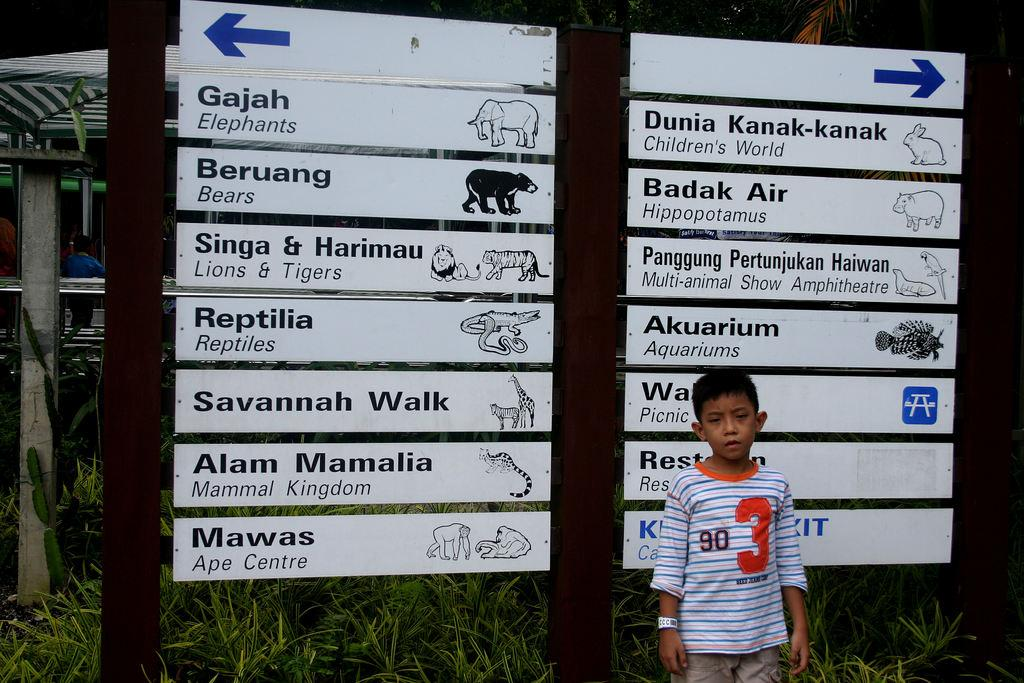Who is present in the image? There is a boy in the image. What is the boy standing near? The boy is standing near a board. What can be found on the board? The board contains text and animal figures. What is visible in the foreground of the image? There is grass visible in the foreground of the image. What type of bedroom furniture can be seen in the image? There is no bedroom furniture present in the image; it features a boy standing near a board with text and animal figures. What kind of vessel is the boy using to hold the bun in the image? There is no vessel or bun present in the image. 